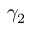Convert formula to latex. <formula><loc_0><loc_0><loc_500><loc_500>\gamma _ { 2 }</formula> 